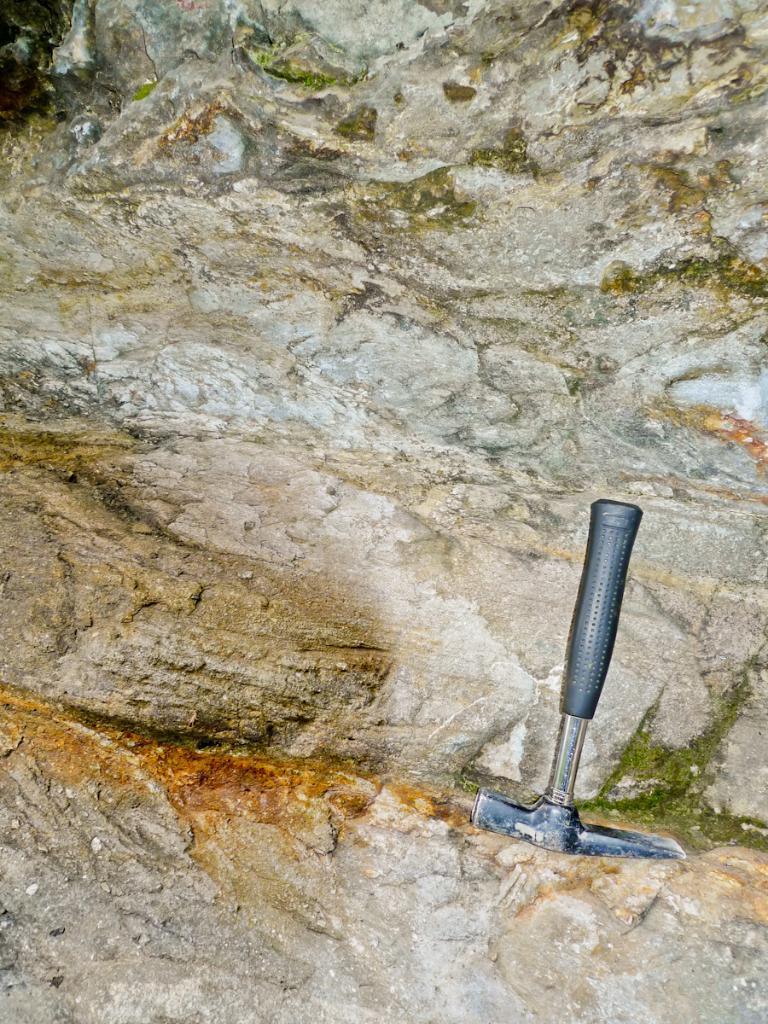What tool is visible in the image? There is a hammer in the image. What object is near the hammer? There is a rock in the image. What is covering the rock? Algae is present on the rock. What type of toothbrush is being used to clean the algae off the rock? There is no toothbrush present in the image, and therefore no such cleaning activity can be observed. 